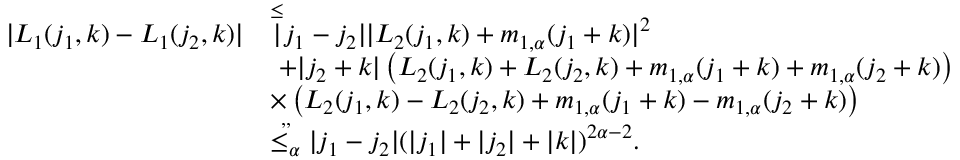Convert formula to latex. <formula><loc_0><loc_0><loc_500><loc_500>\begin{array} { r l } { | L _ { 1 } ( j _ { 1 } , k ) - L _ { 1 } ( j _ { 2 } , k ) | } & { \overset { \leq } { | } j _ { 1 } - j _ { 2 } | | L _ { 2 } ( j _ { 1 } , k ) + m _ { 1 , \alpha } ( j _ { 1 } + k ) | ^ { 2 } } \\ & { \ + | j _ { 2 } + k | \left ( L _ { 2 } ( j _ { 1 } , k ) + L _ { 2 } ( j _ { 2 } , k ) + m _ { 1 , \alpha } ( j _ { 1 } + k ) + m _ { 1 , \alpha } ( j _ { 2 } + k ) \right ) } \\ & { \times \left ( L _ { 2 } ( j _ { 1 } , k ) - L _ { 2 } ( j _ { 2 } , k ) + m _ { 1 , \alpha } ( j _ { 1 } + k ) - m _ { 1 , \alpha } ( j _ { 2 } + k ) \right ) } \\ & { \overset { , , } { \leq _ { \alpha } } | j _ { 1 } - j _ { 2 } | ( | j _ { 1 } | + | j _ { 2 } | + | k | ) ^ { 2 \alpha - 2 } . } \end{array}</formula> 